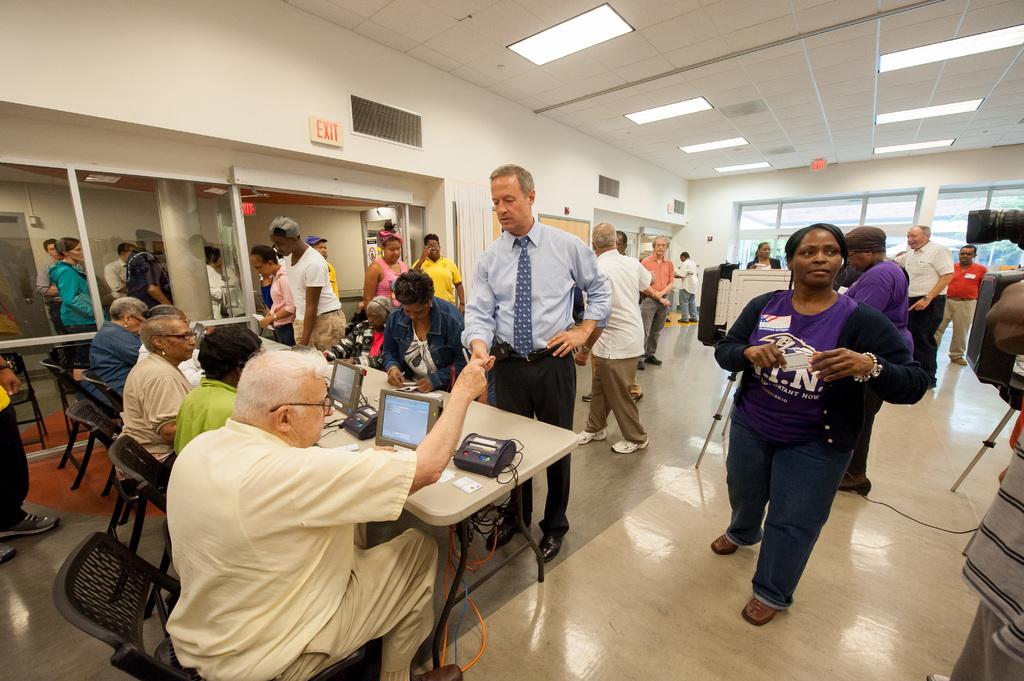Are there three red exit lights there?
Make the answer very short. Yes. 